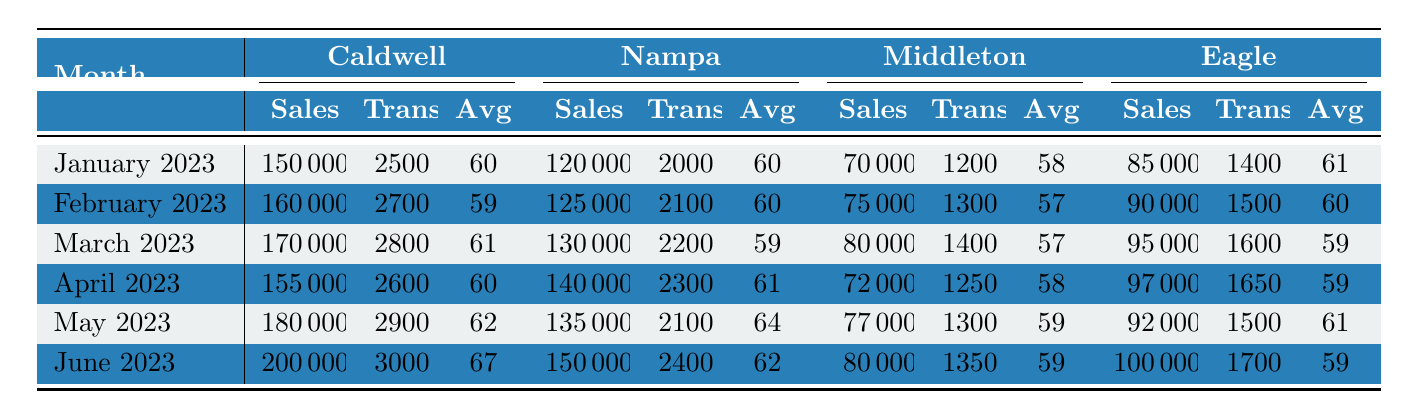What were Caldwell's sales in March 2023? According to the table, Caldwell's sales in March 2023 are listed as 170,000.
Answer: 170000 Which month had the highest average transaction value in Caldwell? Looking at Caldwell's average transaction values, the values are 60, 59, 61, 60, 62, and 67. The highest is 67 in June 2023.
Answer: June 2023 What is the total sales for Nampa from January to April 2023? The sales for Nampa from January to April 2023 are: 120,000, 125,000, 130,000, and 140,000. Adding these gives 120,000 + 125,000 + 130,000 + 140,000 = 515,000.
Answer: 515000 Did Eagle have more sales than Middleton in every month listed? Comparing the sales for Eagle and Middleton: January (85,000 vs. 70,000), February (90,000 vs. 75,000), March (95,000 vs. 80,000), April (97,000 vs. 72,000), May (92,000 vs. 77,000), June (100,000 vs. 80,000). In every month, Eagle's sales exceed Middleton's.
Answer: Yes What was the change in Caldwell's sales from January to June 2023? Caldwell's sales in January were 150,000 and in June were 200,000. The change is calculated as 200,000 - 150,000 = 50,000.
Answer: 50000 Which month had the highest number of transactions in Middleton? The number of transactions for Middleton from January to June 2023 are 1,200, 1,300, 1,400, 1,250, 1,300, and 1,350. The highest is 1,400 in March 2023.
Answer: March 2023 What are the average transaction values in Nampa for the first half of 2023? The average transaction values in Nampa for January to June 2023 are 60, 60, 59, 61, 64, and 62. To find the average, calculate (60 + 60 + 59 + 61 + 64 + 62)/6 = 62.
Answer: 62 Which store had the least sales in April 2023? In April 2023, Caldwell had sales of 155,000, Nampa had 140,000, Middleton had 72,000, and Eagle had 97,000. The least sales were in Middleton at 72,000.
Answer: Middleton How much higher were Caldwell's sales in May 2023 compared to Eagle's sales in the same month? Caldwell's sales in May 2023 were 180,000, and Eagle's were 92,000. The difference is 180,000 - 92,000 = 88,000.
Answer: 88000 What was the total number of transactions across all stores in January 2023? The total transactions in January 2023 are 2,500 (Caldwell) + 2,000 (Nampa) + 1,200 (Middleton) + 1,400 (Eagle) = 7,100.
Answer: 7100 